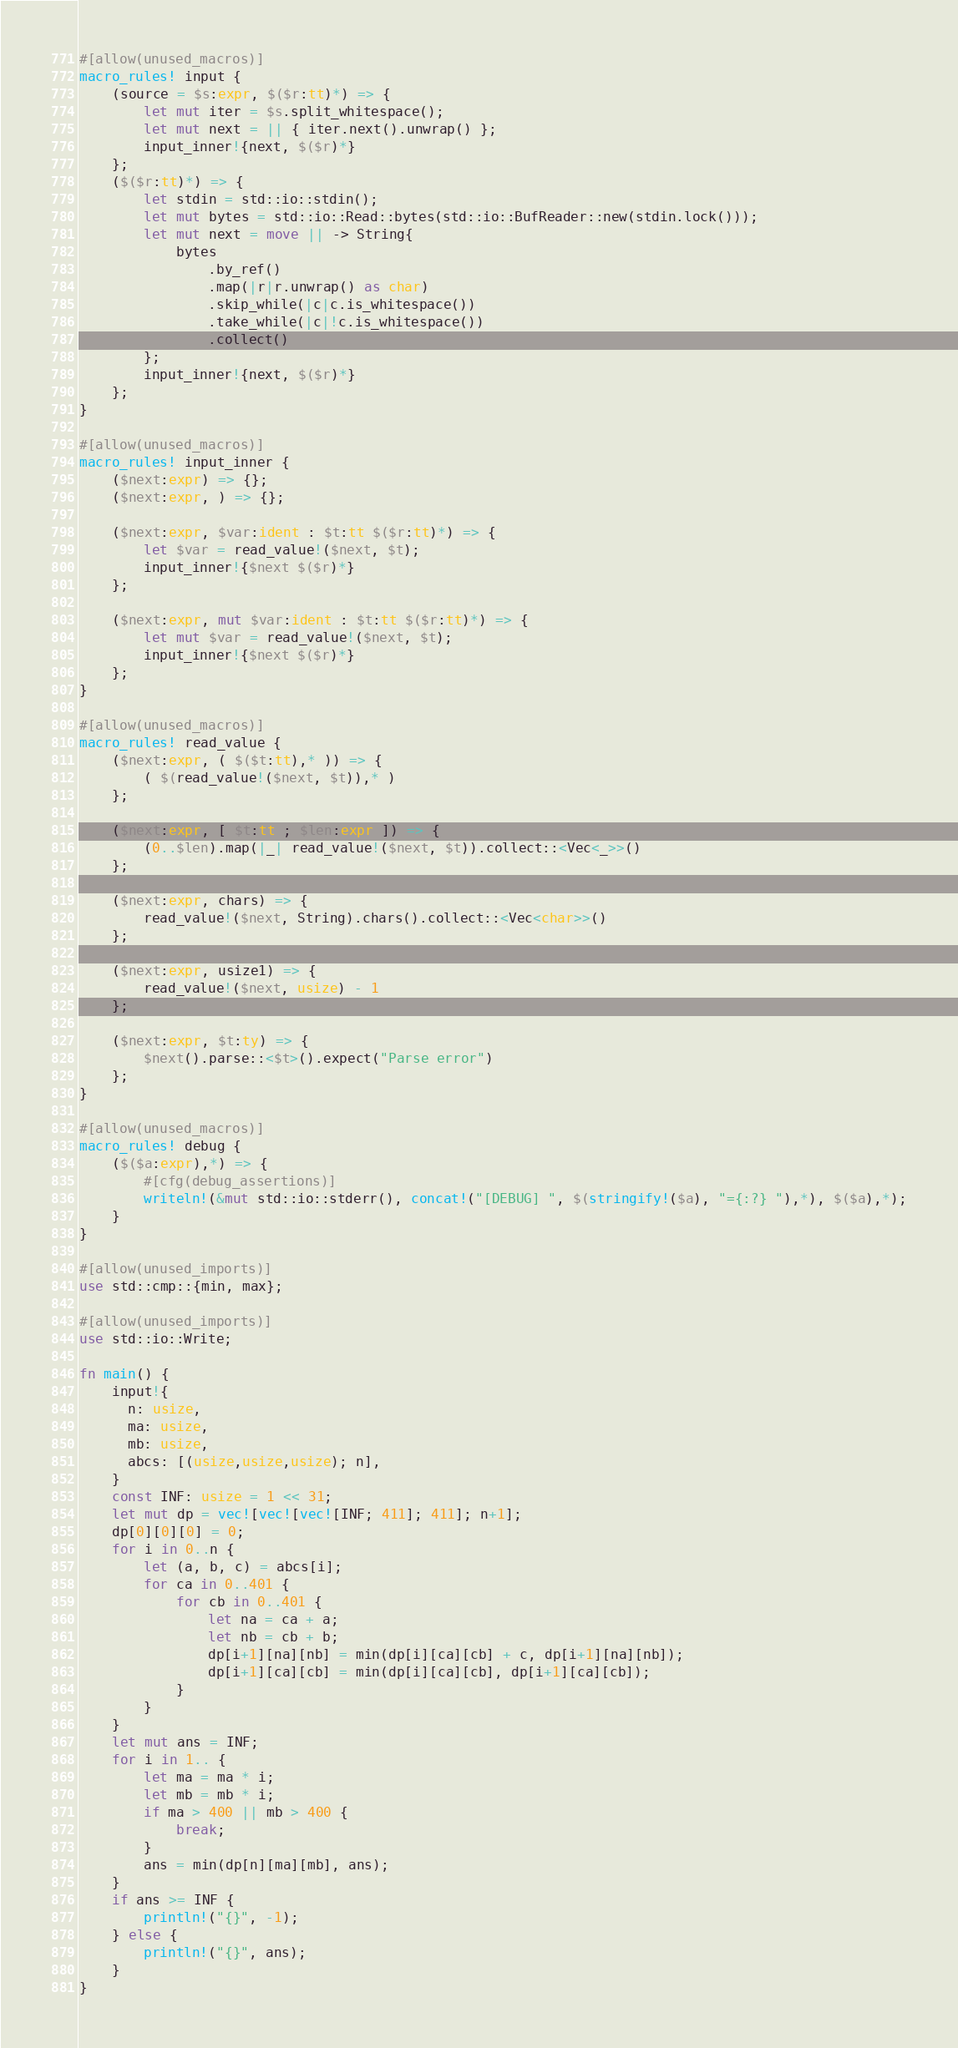<code> <loc_0><loc_0><loc_500><loc_500><_Rust_>#[allow(unused_macros)]
macro_rules! input {
    (source = $s:expr, $($r:tt)*) => {
        let mut iter = $s.split_whitespace();
        let mut next = || { iter.next().unwrap() };
        input_inner!{next, $($r)*}
    };
    ($($r:tt)*) => {
        let stdin = std::io::stdin();
        let mut bytes = std::io::Read::bytes(std::io::BufReader::new(stdin.lock()));
        let mut next = move || -> String{
            bytes
                .by_ref()
                .map(|r|r.unwrap() as char)
                .skip_while(|c|c.is_whitespace())
                .take_while(|c|!c.is_whitespace())
                .collect()
        };
        input_inner!{next, $($r)*}
    };
}

#[allow(unused_macros)]
macro_rules! input_inner {
    ($next:expr) => {};
    ($next:expr, ) => {};

    ($next:expr, $var:ident : $t:tt $($r:tt)*) => {
        let $var = read_value!($next, $t);
        input_inner!{$next $($r)*}
    };

    ($next:expr, mut $var:ident : $t:tt $($r:tt)*) => {
        let mut $var = read_value!($next, $t);
        input_inner!{$next $($r)*}
    };
}

#[allow(unused_macros)]
macro_rules! read_value {
    ($next:expr, ( $($t:tt),* )) => {
        ( $(read_value!($next, $t)),* )
    };

    ($next:expr, [ $t:tt ; $len:expr ]) => {
        (0..$len).map(|_| read_value!($next, $t)).collect::<Vec<_>>()
    };

    ($next:expr, chars) => {
        read_value!($next, String).chars().collect::<Vec<char>>()
    };

    ($next:expr, usize1) => {
        read_value!($next, usize) - 1
    };

    ($next:expr, $t:ty) => {
        $next().parse::<$t>().expect("Parse error")
    };
}

#[allow(unused_macros)]
macro_rules! debug {
    ($($a:expr),*) => {
        #[cfg(debug_assertions)]
        writeln!(&mut std::io::stderr(), concat!("[DEBUG] ", $(stringify!($a), "={:?} "),*), $($a),*);
    }
}

#[allow(unused_imports)]
use std::cmp::{min, max};

#[allow(unused_imports)]
use std::io::Write;

fn main() {
    input!{
      n: usize,
      ma: usize,
      mb: usize,
      abcs: [(usize,usize,usize); n],
    }
    const INF: usize = 1 << 31;
    let mut dp = vec![vec![vec![INF; 411]; 411]; n+1];
    dp[0][0][0] = 0;
    for i in 0..n {
        let (a, b, c) = abcs[i];
        for ca in 0..401 {
            for cb in 0..401 {
                let na = ca + a;
                let nb = cb + b;
                dp[i+1][na][nb] = min(dp[i][ca][cb] + c, dp[i+1][na][nb]);
                dp[i+1][ca][cb] = min(dp[i][ca][cb], dp[i+1][ca][cb]);
            }
        }
    }
    let mut ans = INF;
    for i in 1.. {
        let ma = ma * i;
        let mb = mb * i;
        if ma > 400 || mb > 400 {
            break;
        }
        ans = min(dp[n][ma][mb], ans);
    }
    if ans >= INF {
        println!("{}", -1);
    } else {
        println!("{}", ans);
    }
}
</code> 